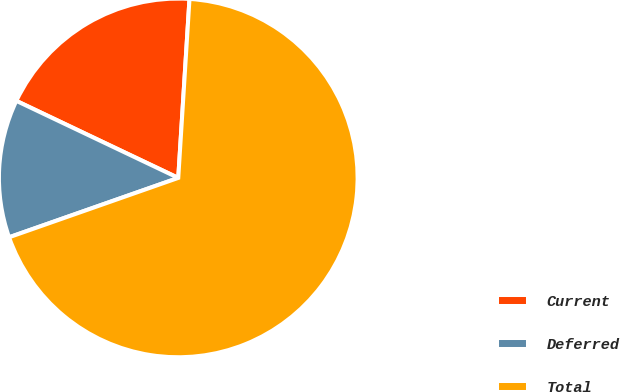Convert chart. <chart><loc_0><loc_0><loc_500><loc_500><pie_chart><fcel>Current<fcel>Deferred<fcel>Total<nl><fcel>18.93%<fcel>12.44%<fcel>68.63%<nl></chart> 